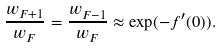Convert formula to latex. <formula><loc_0><loc_0><loc_500><loc_500>\frac { w _ { F + 1 } } { w _ { F } } = \frac { w _ { F - 1 } } { w _ { F } } \approx \exp ( - f ^ { \prime } ( 0 ) ) .</formula> 